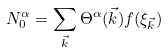Convert formula to latex. <formula><loc_0><loc_0><loc_500><loc_500>N ^ { \alpha } _ { 0 } = \sum _ { \vec { k } } \Theta ^ { \alpha } ( { \vec { k } } ) f ( \xi _ { \vec { k } } )</formula> 